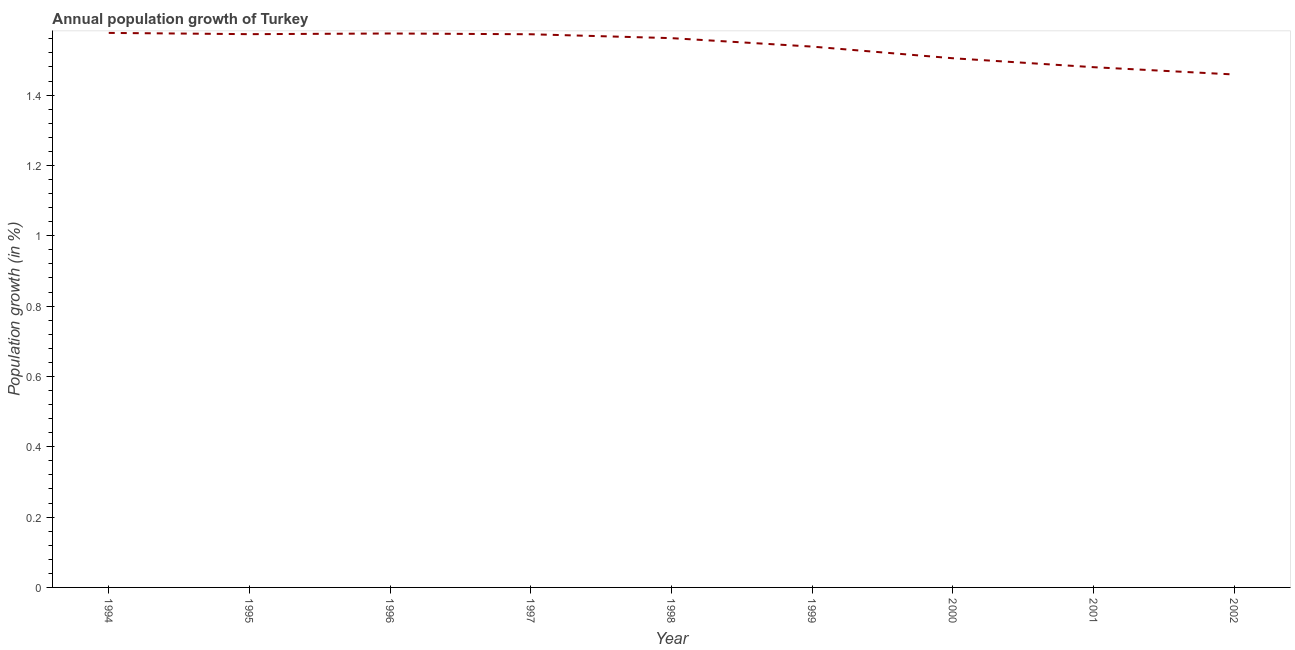What is the population growth in 1998?
Your response must be concise. 1.56. Across all years, what is the maximum population growth?
Your answer should be very brief. 1.58. Across all years, what is the minimum population growth?
Offer a terse response. 1.46. In which year was the population growth maximum?
Your answer should be compact. 1994. What is the sum of the population growth?
Keep it short and to the point. 13.84. What is the difference between the population growth in 2000 and 2002?
Offer a very short reply. 0.05. What is the average population growth per year?
Ensure brevity in your answer.  1.54. What is the median population growth?
Your response must be concise. 1.56. What is the ratio of the population growth in 1997 to that in 2001?
Give a very brief answer. 1.06. Is the difference between the population growth in 1994 and 1998 greater than the difference between any two years?
Make the answer very short. No. What is the difference between the highest and the second highest population growth?
Provide a succinct answer. 0. Is the sum of the population growth in 1995 and 2001 greater than the maximum population growth across all years?
Make the answer very short. Yes. What is the difference between the highest and the lowest population growth?
Offer a terse response. 0.12. In how many years, is the population growth greater than the average population growth taken over all years?
Your answer should be compact. 6. Does the population growth monotonically increase over the years?
Offer a very short reply. No. How many years are there in the graph?
Your answer should be compact. 9. Are the values on the major ticks of Y-axis written in scientific E-notation?
Offer a very short reply. No. Does the graph contain any zero values?
Make the answer very short. No. Does the graph contain grids?
Ensure brevity in your answer.  No. What is the title of the graph?
Your answer should be compact. Annual population growth of Turkey. What is the label or title of the Y-axis?
Ensure brevity in your answer.  Population growth (in %). What is the Population growth (in %) in 1994?
Provide a short and direct response. 1.58. What is the Population growth (in %) of 1995?
Offer a very short reply. 1.57. What is the Population growth (in %) in 1996?
Ensure brevity in your answer.  1.58. What is the Population growth (in %) of 1997?
Give a very brief answer. 1.57. What is the Population growth (in %) of 1998?
Offer a very short reply. 1.56. What is the Population growth (in %) in 1999?
Keep it short and to the point. 1.54. What is the Population growth (in %) of 2000?
Your answer should be very brief. 1.5. What is the Population growth (in %) in 2001?
Provide a succinct answer. 1.48. What is the Population growth (in %) in 2002?
Make the answer very short. 1.46. What is the difference between the Population growth (in %) in 1994 and 1995?
Keep it short and to the point. 0. What is the difference between the Population growth (in %) in 1994 and 1996?
Provide a succinct answer. 0. What is the difference between the Population growth (in %) in 1994 and 1997?
Give a very brief answer. 0. What is the difference between the Population growth (in %) in 1994 and 1998?
Make the answer very short. 0.01. What is the difference between the Population growth (in %) in 1994 and 1999?
Your response must be concise. 0.04. What is the difference between the Population growth (in %) in 1994 and 2000?
Your answer should be very brief. 0.07. What is the difference between the Population growth (in %) in 1994 and 2001?
Provide a succinct answer. 0.1. What is the difference between the Population growth (in %) in 1994 and 2002?
Make the answer very short. 0.12. What is the difference between the Population growth (in %) in 1995 and 1996?
Give a very brief answer. -0. What is the difference between the Population growth (in %) in 1995 and 1997?
Your answer should be compact. 0. What is the difference between the Population growth (in %) in 1995 and 1998?
Provide a succinct answer. 0.01. What is the difference between the Population growth (in %) in 1995 and 1999?
Your answer should be compact. 0.04. What is the difference between the Population growth (in %) in 1995 and 2000?
Offer a terse response. 0.07. What is the difference between the Population growth (in %) in 1995 and 2001?
Provide a short and direct response. 0.09. What is the difference between the Population growth (in %) in 1995 and 2002?
Keep it short and to the point. 0.11. What is the difference between the Population growth (in %) in 1996 and 1997?
Keep it short and to the point. 0. What is the difference between the Population growth (in %) in 1996 and 1998?
Ensure brevity in your answer.  0.01. What is the difference between the Population growth (in %) in 1996 and 1999?
Your answer should be compact. 0.04. What is the difference between the Population growth (in %) in 1996 and 2000?
Provide a succinct answer. 0.07. What is the difference between the Population growth (in %) in 1996 and 2001?
Ensure brevity in your answer.  0.1. What is the difference between the Population growth (in %) in 1996 and 2002?
Offer a terse response. 0.12. What is the difference between the Population growth (in %) in 1997 and 1998?
Offer a terse response. 0.01. What is the difference between the Population growth (in %) in 1997 and 1999?
Give a very brief answer. 0.04. What is the difference between the Population growth (in %) in 1997 and 2000?
Your response must be concise. 0.07. What is the difference between the Population growth (in %) in 1997 and 2001?
Offer a terse response. 0.09. What is the difference between the Population growth (in %) in 1997 and 2002?
Provide a succinct answer. 0.11. What is the difference between the Population growth (in %) in 1998 and 1999?
Offer a terse response. 0.02. What is the difference between the Population growth (in %) in 1998 and 2000?
Your answer should be very brief. 0.06. What is the difference between the Population growth (in %) in 1998 and 2001?
Your answer should be very brief. 0.08. What is the difference between the Population growth (in %) in 1998 and 2002?
Give a very brief answer. 0.1. What is the difference between the Population growth (in %) in 1999 and 2000?
Keep it short and to the point. 0.03. What is the difference between the Population growth (in %) in 1999 and 2001?
Make the answer very short. 0.06. What is the difference between the Population growth (in %) in 1999 and 2002?
Offer a terse response. 0.08. What is the difference between the Population growth (in %) in 2000 and 2001?
Make the answer very short. 0.03. What is the difference between the Population growth (in %) in 2000 and 2002?
Offer a terse response. 0.05. What is the difference between the Population growth (in %) in 2001 and 2002?
Your answer should be compact. 0.02. What is the ratio of the Population growth (in %) in 1994 to that in 1995?
Your answer should be very brief. 1. What is the ratio of the Population growth (in %) in 1994 to that in 1996?
Your response must be concise. 1. What is the ratio of the Population growth (in %) in 1994 to that in 1998?
Keep it short and to the point. 1.01. What is the ratio of the Population growth (in %) in 1994 to that in 2000?
Offer a terse response. 1.05. What is the ratio of the Population growth (in %) in 1994 to that in 2001?
Your response must be concise. 1.07. What is the ratio of the Population growth (in %) in 1994 to that in 2002?
Your answer should be compact. 1.08. What is the ratio of the Population growth (in %) in 1995 to that in 1996?
Offer a terse response. 1. What is the ratio of the Population growth (in %) in 1995 to that in 1997?
Provide a short and direct response. 1. What is the ratio of the Population growth (in %) in 1995 to that in 1998?
Your answer should be compact. 1.01. What is the ratio of the Population growth (in %) in 1995 to that in 1999?
Provide a succinct answer. 1.02. What is the ratio of the Population growth (in %) in 1995 to that in 2000?
Your response must be concise. 1.05. What is the ratio of the Population growth (in %) in 1995 to that in 2001?
Give a very brief answer. 1.06. What is the ratio of the Population growth (in %) in 1995 to that in 2002?
Provide a short and direct response. 1.08. What is the ratio of the Population growth (in %) in 1996 to that in 2000?
Keep it short and to the point. 1.05. What is the ratio of the Population growth (in %) in 1996 to that in 2001?
Offer a terse response. 1.06. What is the ratio of the Population growth (in %) in 1996 to that in 2002?
Make the answer very short. 1.08. What is the ratio of the Population growth (in %) in 1997 to that in 1999?
Keep it short and to the point. 1.02. What is the ratio of the Population growth (in %) in 1997 to that in 2000?
Your answer should be very brief. 1.04. What is the ratio of the Population growth (in %) in 1997 to that in 2001?
Make the answer very short. 1.06. What is the ratio of the Population growth (in %) in 1997 to that in 2002?
Your answer should be compact. 1.08. What is the ratio of the Population growth (in %) in 1998 to that in 2000?
Provide a succinct answer. 1.04. What is the ratio of the Population growth (in %) in 1998 to that in 2001?
Give a very brief answer. 1.06. What is the ratio of the Population growth (in %) in 1998 to that in 2002?
Keep it short and to the point. 1.07. What is the ratio of the Population growth (in %) in 1999 to that in 2001?
Provide a succinct answer. 1.04. What is the ratio of the Population growth (in %) in 1999 to that in 2002?
Give a very brief answer. 1.05. What is the ratio of the Population growth (in %) in 2000 to that in 2002?
Ensure brevity in your answer.  1.03. 